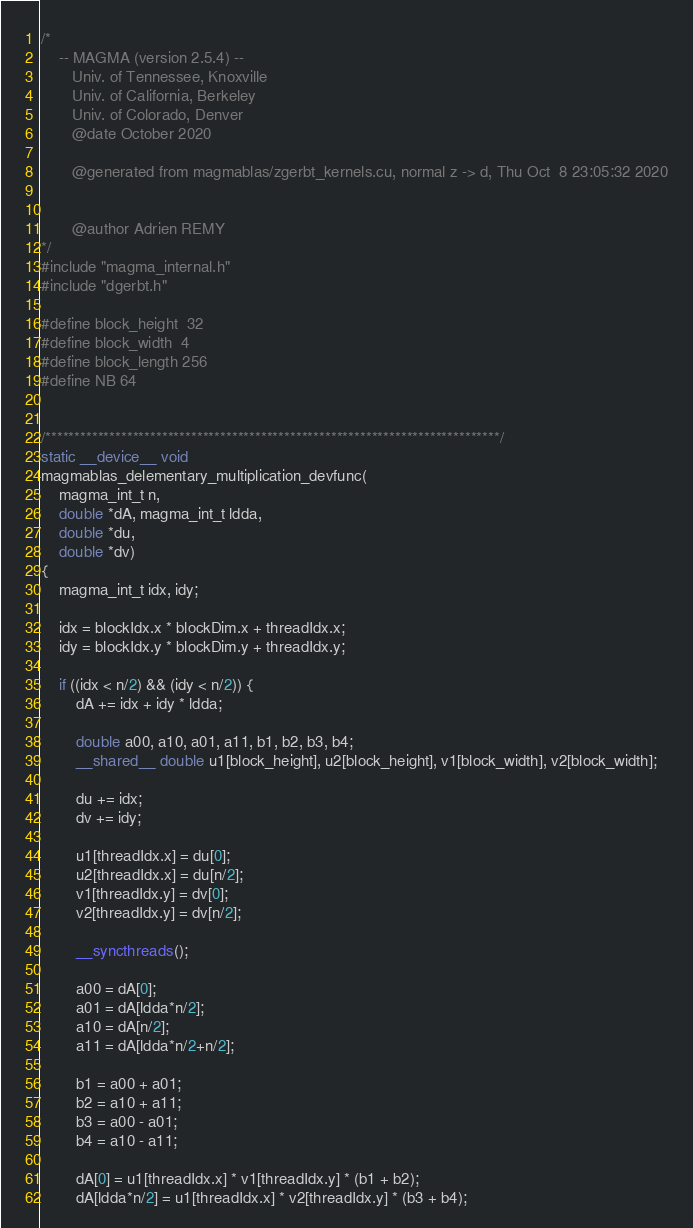Convert code to text. <code><loc_0><loc_0><loc_500><loc_500><_Cuda_>/*
    -- MAGMA (version 2.5.4) --
       Univ. of Tennessee, Knoxville
       Univ. of California, Berkeley
       Univ. of Colorado, Denver
       @date October 2020

       @generated from magmablas/zgerbt_kernels.cu, normal z -> d, Thu Oct  8 23:05:32 2020


       @author Adrien REMY
*/
#include "magma_internal.h"
#include "dgerbt.h"

#define block_height  32
#define block_width  4
#define block_length 256
#define NB 64


/******************************************************************************/
static __device__ void 
magmablas_delementary_multiplication_devfunc(
    magma_int_t n,
    double *dA, magma_int_t ldda, 
    double *du, 
    double *dv)
{    
    magma_int_t idx, idy;

    idx = blockIdx.x * blockDim.x + threadIdx.x;
    idy = blockIdx.y * blockDim.y + threadIdx.y;

    if ((idx < n/2) && (idy < n/2)) {
        dA += idx + idy * ldda;

        double a00, a10, a01, a11, b1, b2, b3, b4;
        __shared__ double u1[block_height], u2[block_height], v1[block_width], v2[block_width];

        du += idx;
        dv += idy;

        u1[threadIdx.x] = du[0];
        u2[threadIdx.x] = du[n/2];
        v1[threadIdx.y] = dv[0];
        v2[threadIdx.y] = dv[n/2];

        __syncthreads();

        a00 = dA[0];
        a01 = dA[ldda*n/2];
        a10 = dA[n/2];
        a11 = dA[ldda*n/2+n/2];

        b1 = a00 + a01;
        b2 = a10 + a11;
        b3 = a00 - a01;
        b4 = a10 - a11;

        dA[0] = u1[threadIdx.x] * v1[threadIdx.y] * (b1 + b2);
        dA[ldda*n/2] = u1[threadIdx.x] * v2[threadIdx.y] * (b3 + b4);</code> 